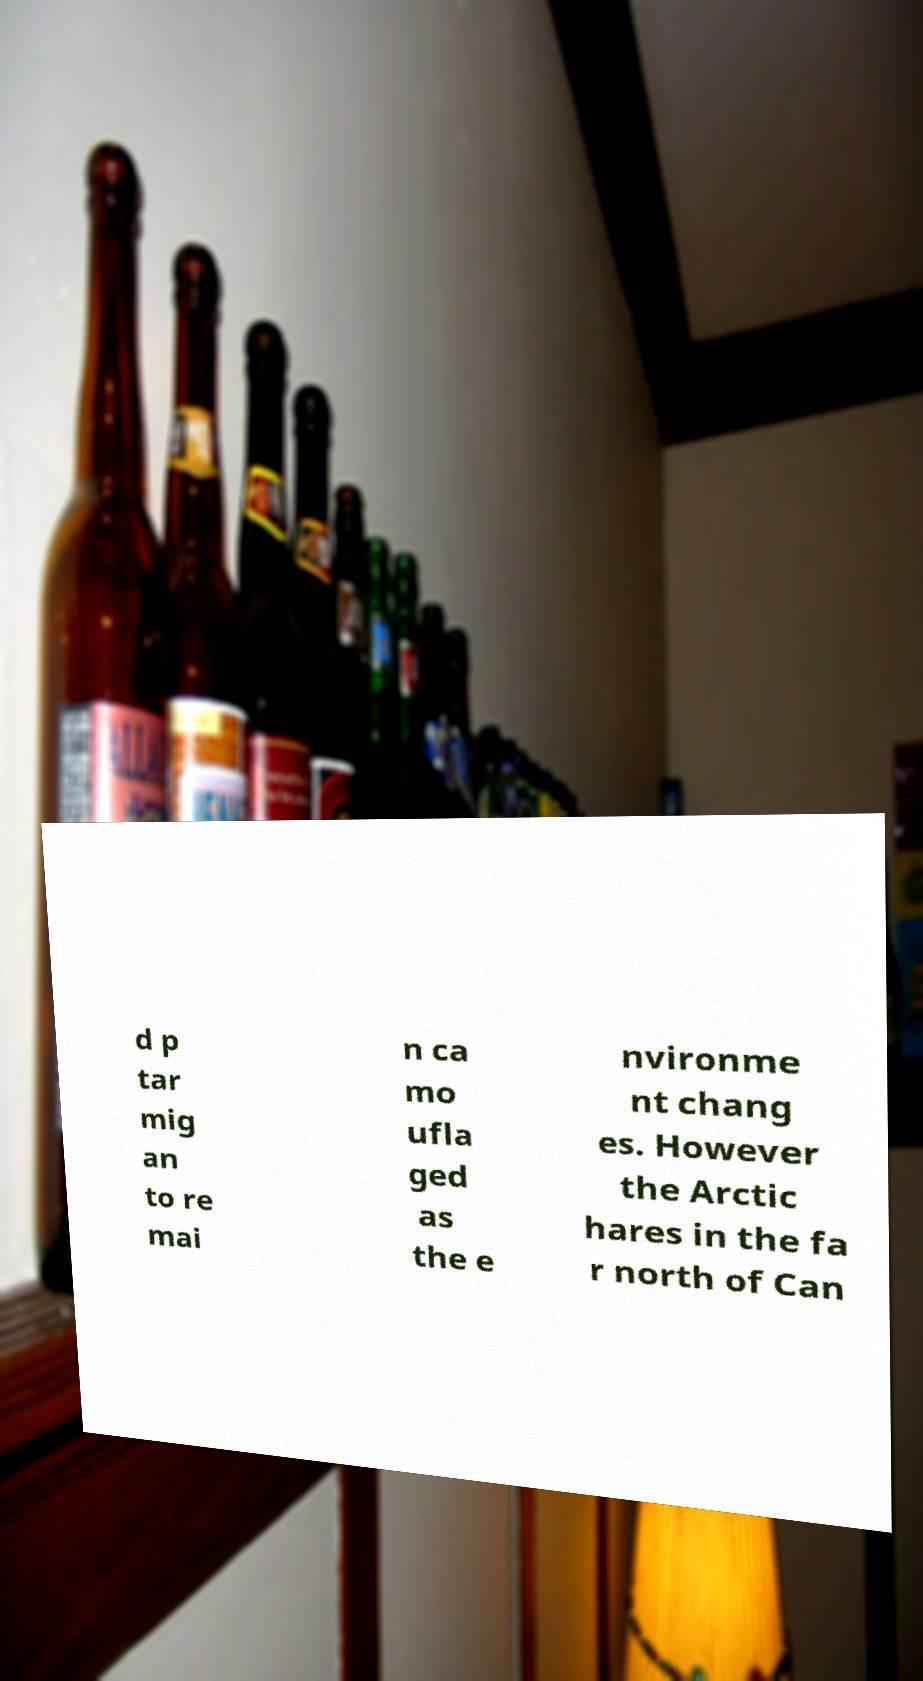I need the written content from this picture converted into text. Can you do that? d p tar mig an to re mai n ca mo ufla ged as the e nvironme nt chang es. However the Arctic hares in the fa r north of Can 